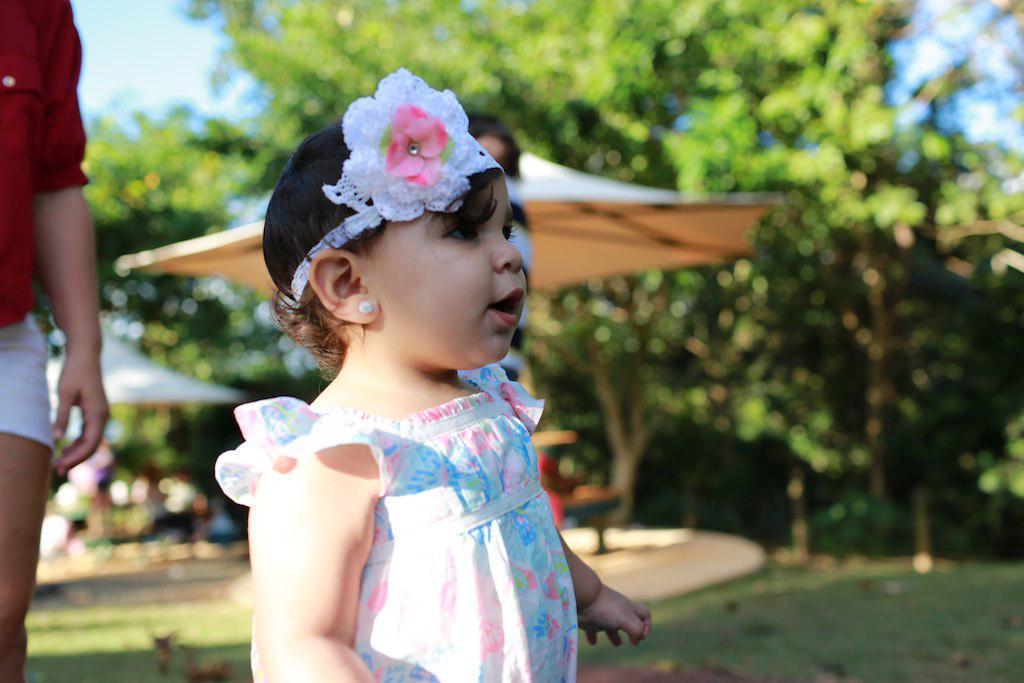Please provide a concise description of this image. There is a kid standing,behind this child we can see a person. Background we can see trees,tents and sky. 